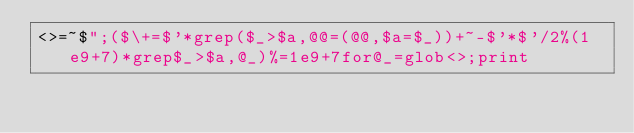<code> <loc_0><loc_0><loc_500><loc_500><_Perl_><>=~$";($\+=$'*grep($_>$a,@@=(@@,$a=$_))+~-$'*$'/2%(1e9+7)*grep$_>$a,@_)%=1e9+7for@_=glob<>;print</code> 